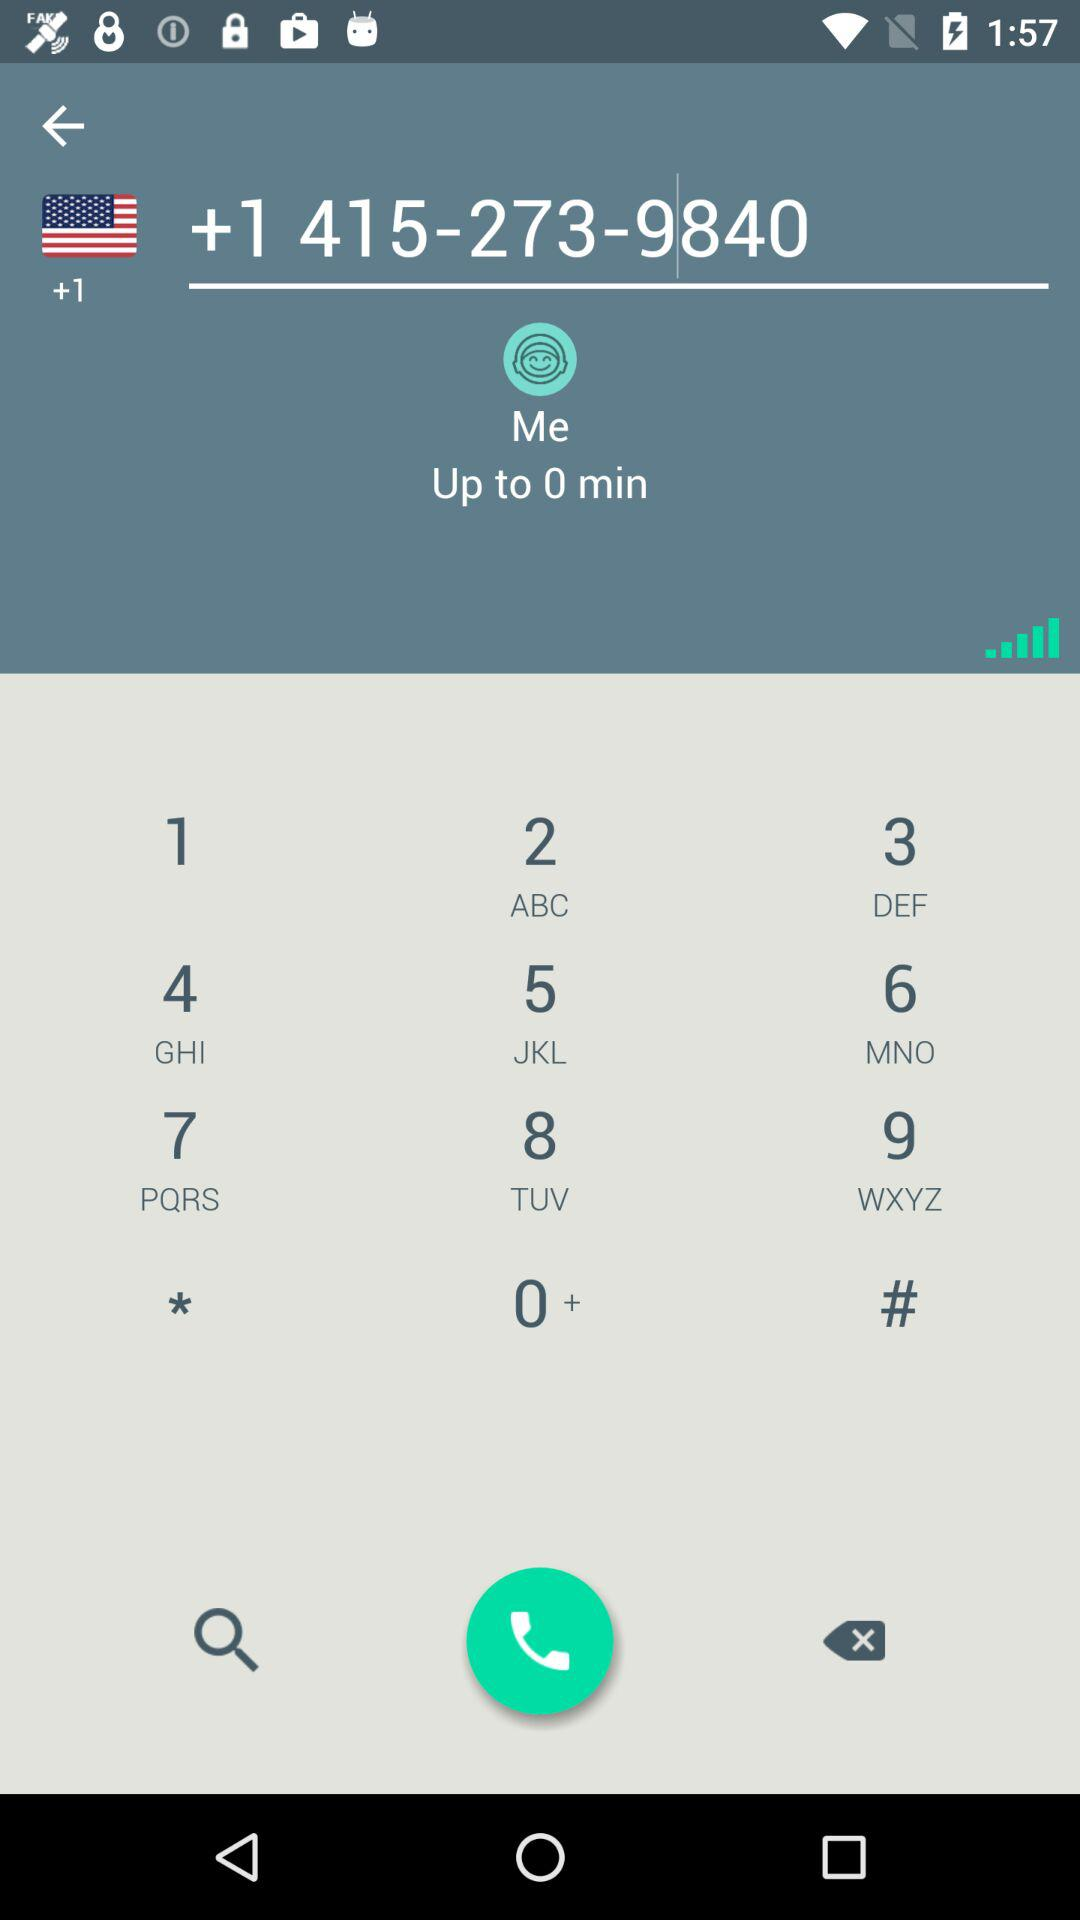How many minutes are mentioned? The mentioned minute is 0. 